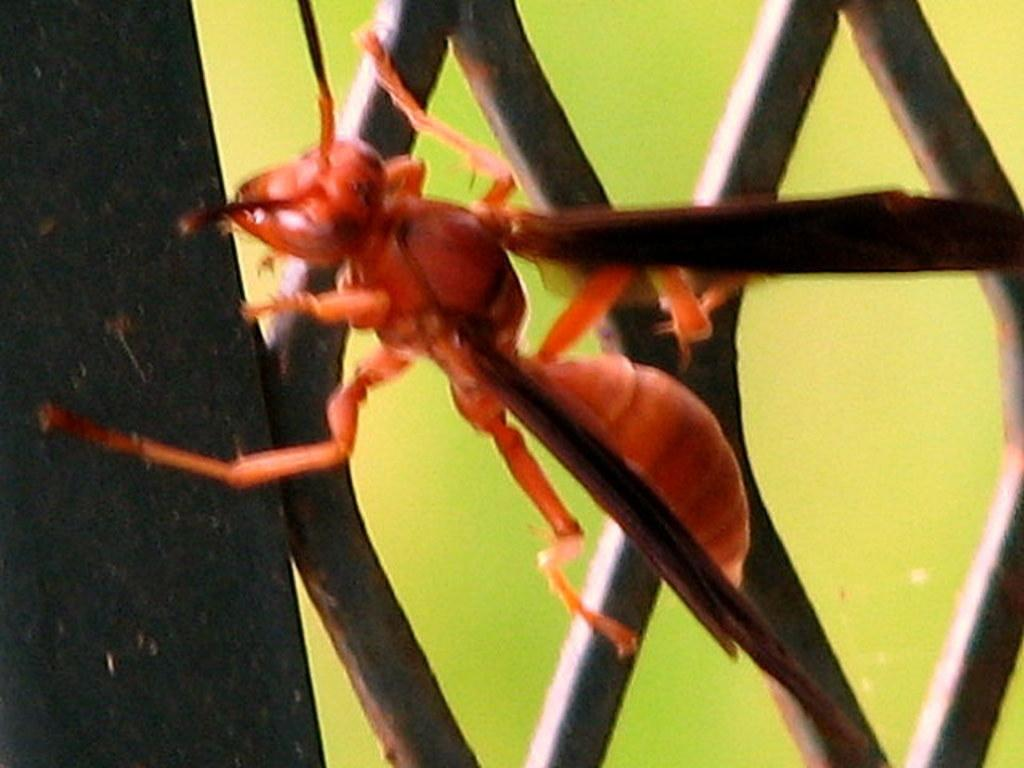What is the main subject of the image? The main subject of the image is an ant. Can you describe the color of the ant? The ant is red in color. Where is the ant located in the image? The ant is on a wooden stand. How would you describe the background of the image? The background of the image is blurry. What type of wool is being used in the hospital in the image? There is no hospital or wool present in the image; it features a red ant on a wooden stand with a blurry background. 